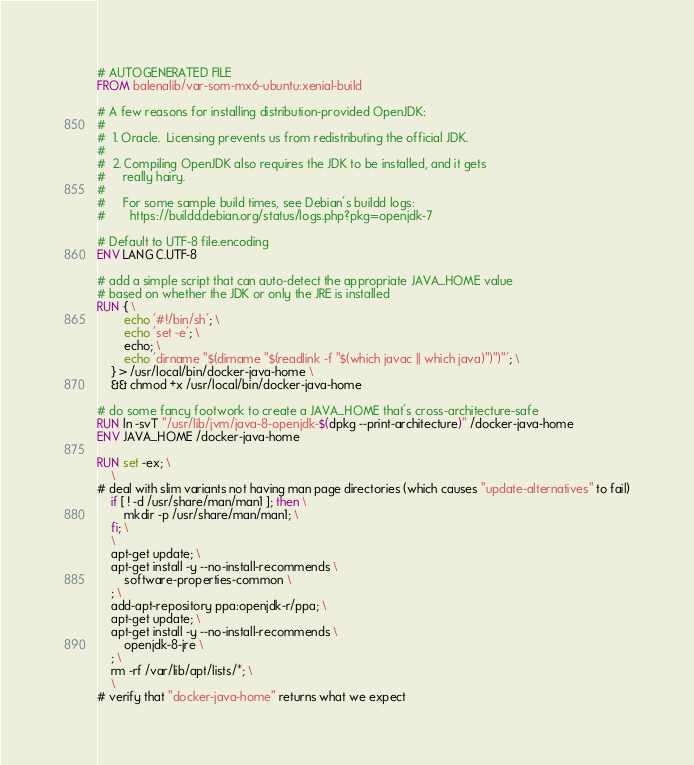<code> <loc_0><loc_0><loc_500><loc_500><_Dockerfile_># AUTOGENERATED FILE
FROM balenalib/var-som-mx6-ubuntu:xenial-build

# A few reasons for installing distribution-provided OpenJDK:
#
#  1. Oracle.  Licensing prevents us from redistributing the official JDK.
#
#  2. Compiling OpenJDK also requires the JDK to be installed, and it gets
#     really hairy.
#
#     For some sample build times, see Debian's buildd logs:
#       https://buildd.debian.org/status/logs.php?pkg=openjdk-7

# Default to UTF-8 file.encoding
ENV LANG C.UTF-8

# add a simple script that can auto-detect the appropriate JAVA_HOME value
# based on whether the JDK or only the JRE is installed
RUN { \
		echo '#!/bin/sh'; \
		echo 'set -e'; \
		echo; \
		echo 'dirname "$(dirname "$(readlink -f "$(which javac || which java)")")"'; \
	} > /usr/local/bin/docker-java-home \
	&& chmod +x /usr/local/bin/docker-java-home

# do some fancy footwork to create a JAVA_HOME that's cross-architecture-safe
RUN ln -svT "/usr/lib/jvm/java-8-openjdk-$(dpkg --print-architecture)" /docker-java-home
ENV JAVA_HOME /docker-java-home

RUN set -ex; \
	\
# deal with slim variants not having man page directories (which causes "update-alternatives" to fail)
	if [ ! -d /usr/share/man/man1 ]; then \
		mkdir -p /usr/share/man/man1; \
	fi; \
	\
	apt-get update; \
	apt-get install -y --no-install-recommends \
		software-properties-common \
	; \
	add-apt-repository ppa:openjdk-r/ppa; \
	apt-get update; \
	apt-get install -y --no-install-recommends \
		openjdk-8-jre \
	; \
	rm -rf /var/lib/apt/lists/*; \
	\
# verify that "docker-java-home" returns what we expect</code> 